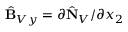<formula> <loc_0><loc_0><loc_500><loc_500>\hat { B } _ { V y } = \partial \hat { N } _ { V } / \partial x _ { 2 }</formula> 